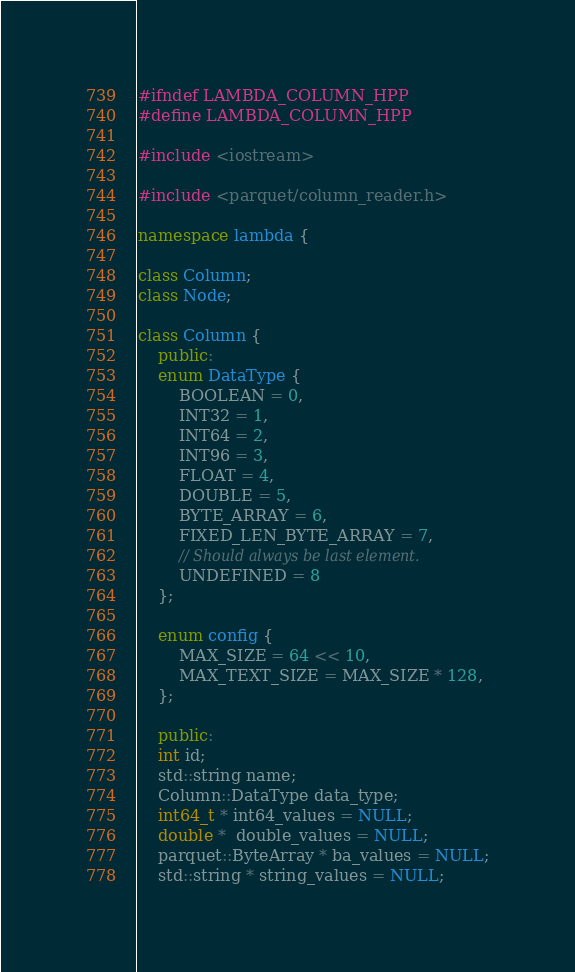Convert code to text. <code><loc_0><loc_0><loc_500><loc_500><_C++_>#ifndef LAMBDA_COLUMN_HPP
#define LAMBDA_COLUMN_HPP

#include <iostream>

#include <parquet/column_reader.h>

namespace lambda {

class Column;
class Node;

class Column {
    public:
    enum DataType {
        BOOLEAN = 0,
        INT32 = 1,
        INT64 = 2,
        INT96 = 3,
        FLOAT = 4,
        DOUBLE = 5,
        BYTE_ARRAY = 6,
        FIXED_LEN_BYTE_ARRAY = 7,
        // Should always be last element.
        UNDEFINED = 8
    };

    enum config {
        MAX_SIZE = 64 << 10,
        MAX_TEXT_SIZE = MAX_SIZE * 128,
    };

    public:
    int id;
    std::string name;
    Column::DataType data_type;
    int64_t * int64_values = NULL;
    double *  double_values = NULL;
    parquet::ByteArray * ba_values = NULL;
    std::string * string_values = NULL;
</code> 